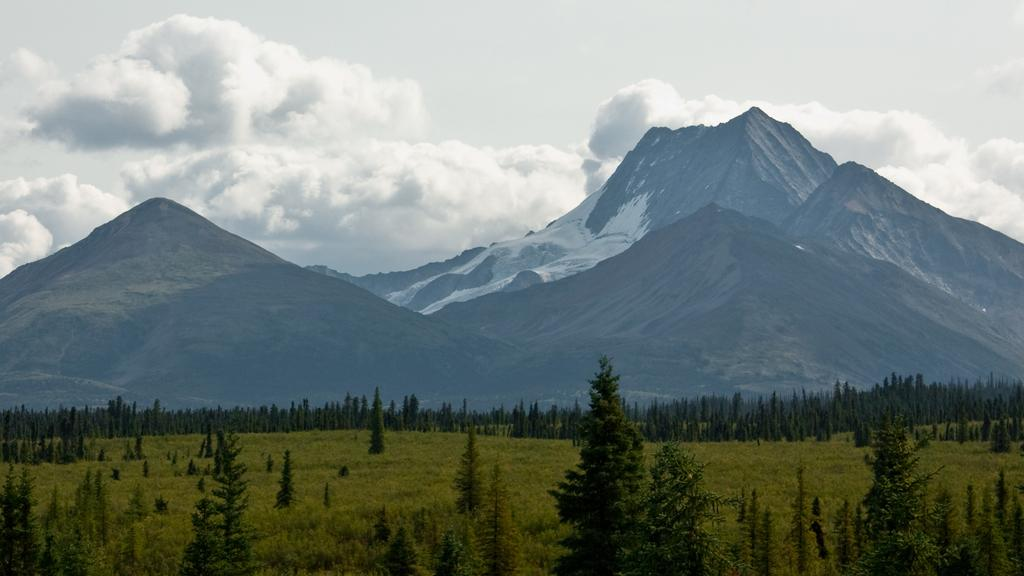What type of vegetation can be seen in the image? There are many trees and plants in the image. What can be seen in the background of the image? There are mountains and the sky visible in the background of the image. What is the condition of the sky in the image? The sky is visible in the background of the image, and clouds are present. What type of stick can be seen in the room in the image? There is no room or stick present in the image; it features trees, plants, mountains, and the sky. 